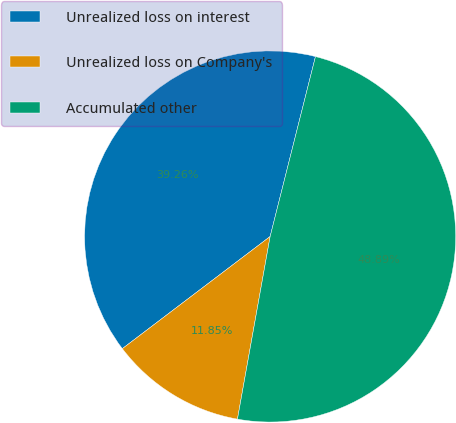Convert chart. <chart><loc_0><loc_0><loc_500><loc_500><pie_chart><fcel>Unrealized loss on interest<fcel>Unrealized loss on Company's<fcel>Accumulated other<nl><fcel>39.26%<fcel>11.85%<fcel>48.89%<nl></chart> 